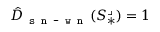Convert formula to latex. <formula><loc_0><loc_0><loc_500><loc_500>\hat { D } _ { s n - w n } ( S _ { * } ^ { \lrcorner } ) = 1</formula> 